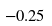<formula> <loc_0><loc_0><loc_500><loc_500>- 0 . 2 5</formula> 